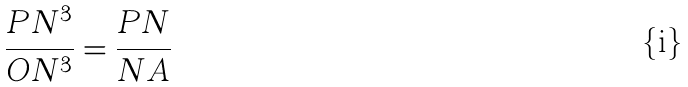<formula> <loc_0><loc_0><loc_500><loc_500>\frac { P N ^ { 3 } } { O N ^ { 3 } } = \frac { P N } { N A }</formula> 